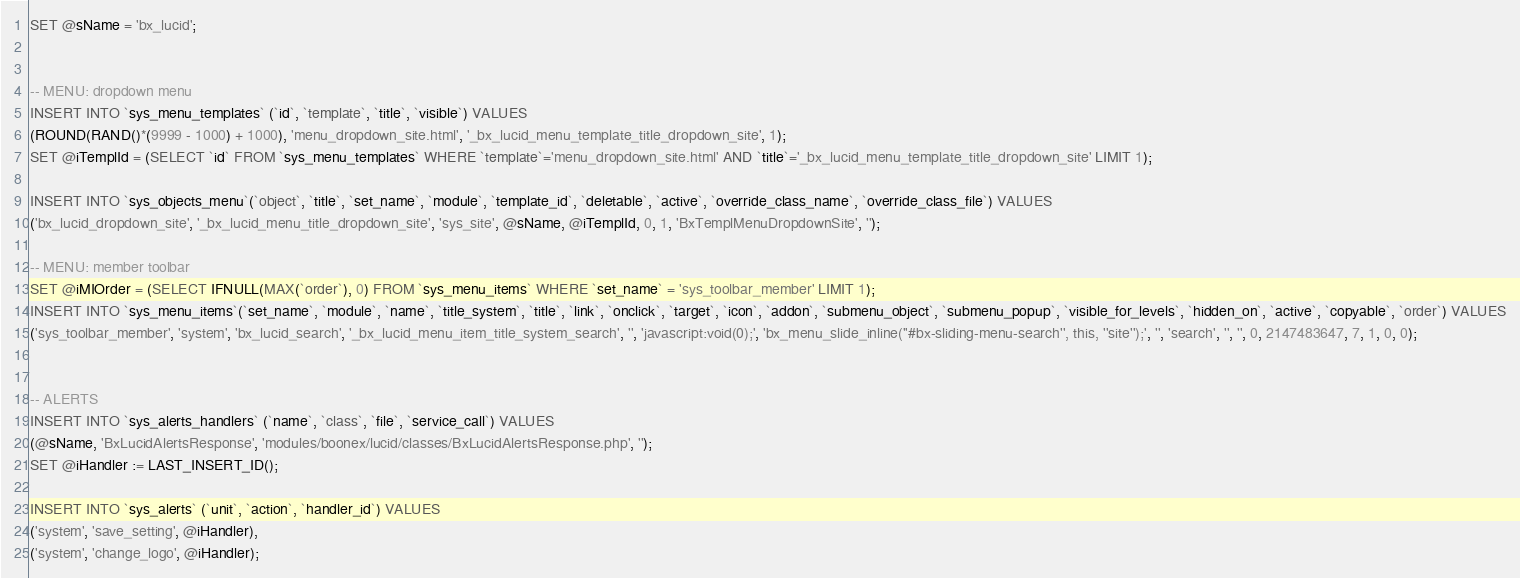<code> <loc_0><loc_0><loc_500><loc_500><_SQL_>SET @sName = 'bx_lucid';


-- MENU: dropdown menu
INSERT INTO `sys_menu_templates` (`id`, `template`, `title`, `visible`) VALUES
(ROUND(RAND()*(9999 - 1000) + 1000), 'menu_dropdown_site.html', '_bx_lucid_menu_template_title_dropdown_site', 1);
SET @iTemplId = (SELECT `id` FROM `sys_menu_templates` WHERE `template`='menu_dropdown_site.html' AND `title`='_bx_lucid_menu_template_title_dropdown_site' LIMIT 1);

INSERT INTO `sys_objects_menu`(`object`, `title`, `set_name`, `module`, `template_id`, `deletable`, `active`, `override_class_name`, `override_class_file`) VALUES 
('bx_lucid_dropdown_site', '_bx_lucid_menu_title_dropdown_site', 'sys_site', @sName, @iTemplId, 0, 1, 'BxTemplMenuDropdownSite', '');

-- MENU: member toolbar
SET @iMIOrder = (SELECT IFNULL(MAX(`order`), 0) FROM `sys_menu_items` WHERE `set_name` = 'sys_toolbar_member' LIMIT 1);
INSERT INTO `sys_menu_items`(`set_name`, `module`, `name`, `title_system`, `title`, `link`, `onclick`, `target`, `icon`, `addon`, `submenu_object`, `submenu_popup`, `visible_for_levels`, `hidden_on`, `active`, `copyable`, `order`) VALUES
('sys_toolbar_member', 'system', 'bx_lucid_search', '_bx_lucid_menu_item_title_system_search', '', 'javascript:void(0);', 'bx_menu_slide_inline(''#bx-sliding-menu-search'', this, ''site'');', '', 'search', '', '', 0, 2147483647, 7, 1, 0, 0);


-- ALERTS
INSERT INTO `sys_alerts_handlers` (`name`, `class`, `file`, `service_call`) VALUES 
(@sName, 'BxLucidAlertsResponse', 'modules/boonex/lucid/classes/BxLucidAlertsResponse.php', '');
SET @iHandler := LAST_INSERT_ID();

INSERT INTO `sys_alerts` (`unit`, `action`, `handler_id`) VALUES
('system', 'save_setting', @iHandler),
('system', 'change_logo', @iHandler);
</code> 